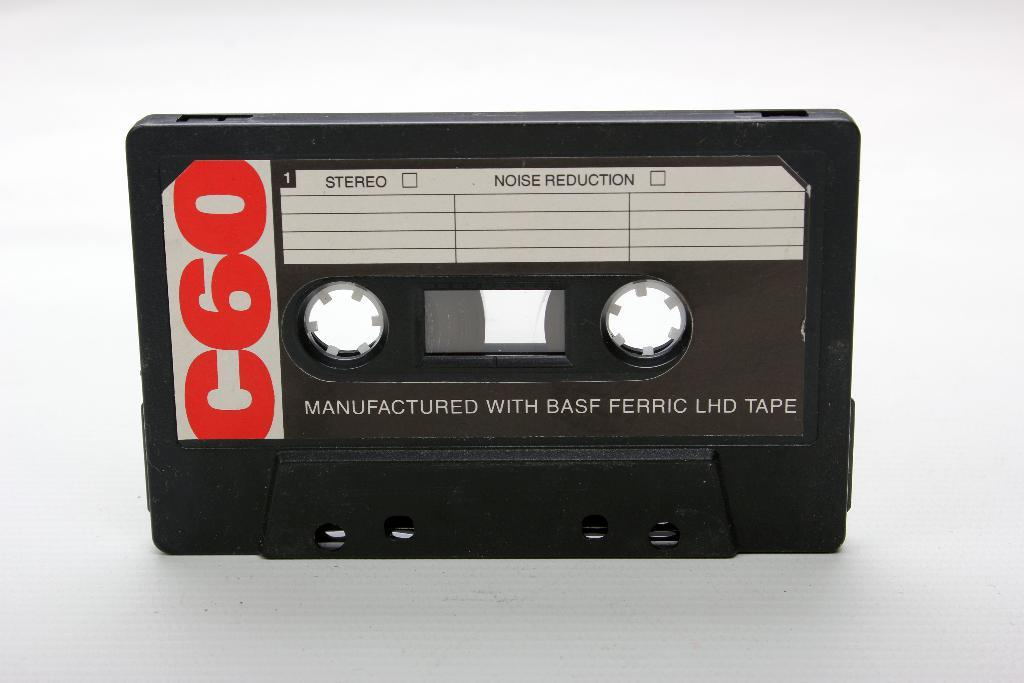What object is the main subject of the image? There is a black cassette in the image. What is the color of the surface on which the cassette is placed? The black cassette is placed on a white surface. How far away is the vacation spot from the location of the image? There is no mention of a vacation spot or any distance in the image, so it cannot be determined. 